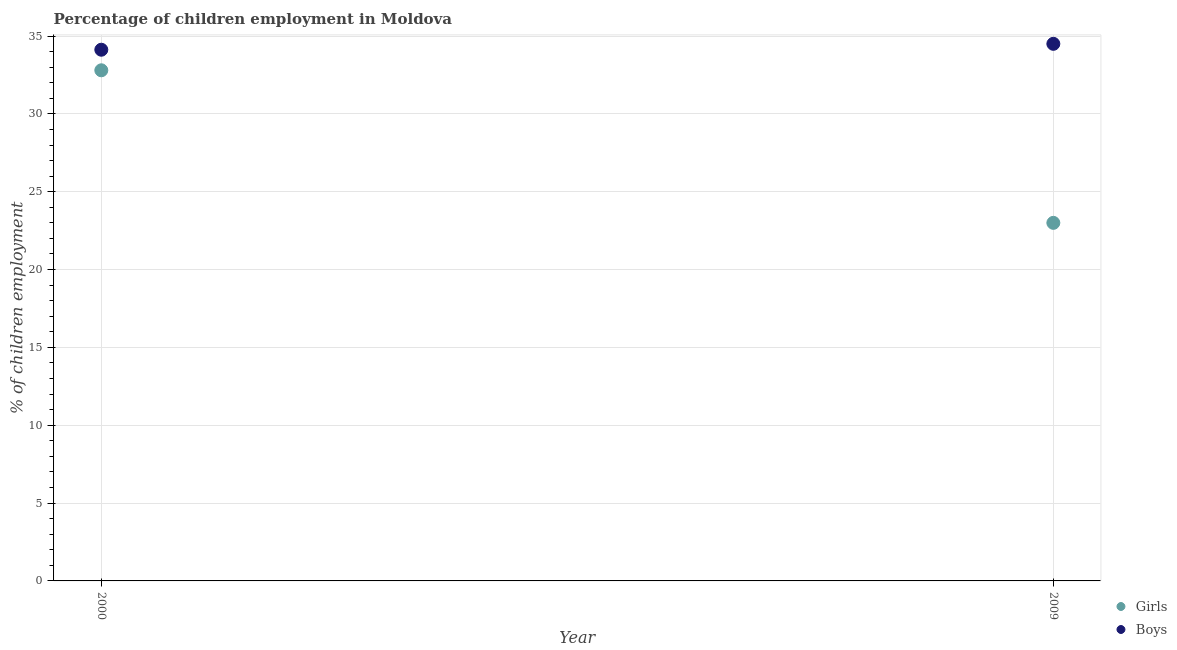Is the number of dotlines equal to the number of legend labels?
Ensure brevity in your answer.  Yes. What is the percentage of employed boys in 2009?
Ensure brevity in your answer.  34.5. Across all years, what is the maximum percentage of employed girls?
Your answer should be very brief. 32.8. Across all years, what is the minimum percentage of employed girls?
Offer a very short reply. 23. In which year was the percentage of employed boys maximum?
Keep it short and to the point. 2009. In which year was the percentage of employed boys minimum?
Keep it short and to the point. 2000. What is the total percentage of employed boys in the graph?
Offer a terse response. 68.62. What is the difference between the percentage of employed boys in 2000 and that in 2009?
Make the answer very short. -0.38. What is the difference between the percentage of employed girls in 2000 and the percentage of employed boys in 2009?
Your answer should be very brief. -1.7. What is the average percentage of employed boys per year?
Your response must be concise. 34.31. In the year 2000, what is the difference between the percentage of employed boys and percentage of employed girls?
Offer a very short reply. 1.32. In how many years, is the percentage of employed boys greater than 22 %?
Provide a short and direct response. 2. What is the ratio of the percentage of employed boys in 2000 to that in 2009?
Provide a succinct answer. 0.99. Is the percentage of employed girls in 2000 less than that in 2009?
Offer a very short reply. No. Does the percentage of employed girls monotonically increase over the years?
Your answer should be very brief. No. Is the percentage of employed girls strictly less than the percentage of employed boys over the years?
Your response must be concise. Yes. How many dotlines are there?
Your answer should be compact. 2. What is the difference between two consecutive major ticks on the Y-axis?
Provide a succinct answer. 5. Are the values on the major ticks of Y-axis written in scientific E-notation?
Provide a succinct answer. No. Does the graph contain any zero values?
Keep it short and to the point. No. Does the graph contain grids?
Your answer should be compact. Yes. How many legend labels are there?
Your answer should be compact. 2. How are the legend labels stacked?
Your answer should be compact. Vertical. What is the title of the graph?
Provide a short and direct response. Percentage of children employment in Moldova. What is the label or title of the Y-axis?
Give a very brief answer. % of children employment. What is the % of children employment in Girls in 2000?
Offer a terse response. 32.8. What is the % of children employment of Boys in 2000?
Give a very brief answer. 34.12. What is the % of children employment of Girls in 2009?
Provide a succinct answer. 23. What is the % of children employment of Boys in 2009?
Offer a terse response. 34.5. Across all years, what is the maximum % of children employment of Girls?
Provide a short and direct response. 32.8. Across all years, what is the maximum % of children employment in Boys?
Ensure brevity in your answer.  34.5. Across all years, what is the minimum % of children employment in Girls?
Make the answer very short. 23. Across all years, what is the minimum % of children employment of Boys?
Keep it short and to the point. 34.12. What is the total % of children employment in Girls in the graph?
Give a very brief answer. 55.8. What is the total % of children employment in Boys in the graph?
Make the answer very short. 68.62. What is the difference between the % of children employment of Girls in 2000 and that in 2009?
Offer a very short reply. 9.8. What is the difference between the % of children employment of Boys in 2000 and that in 2009?
Make the answer very short. -0.38. What is the average % of children employment in Girls per year?
Your answer should be compact. 27.9. What is the average % of children employment in Boys per year?
Your answer should be very brief. 34.31. In the year 2000, what is the difference between the % of children employment in Girls and % of children employment in Boys?
Your response must be concise. -1.32. In the year 2009, what is the difference between the % of children employment of Girls and % of children employment of Boys?
Offer a terse response. -11.5. What is the ratio of the % of children employment in Girls in 2000 to that in 2009?
Offer a terse response. 1.43. What is the ratio of the % of children employment of Boys in 2000 to that in 2009?
Offer a terse response. 0.99. What is the difference between the highest and the second highest % of children employment in Girls?
Ensure brevity in your answer.  9.8. What is the difference between the highest and the second highest % of children employment of Boys?
Your answer should be compact. 0.38. What is the difference between the highest and the lowest % of children employment of Boys?
Ensure brevity in your answer.  0.38. 